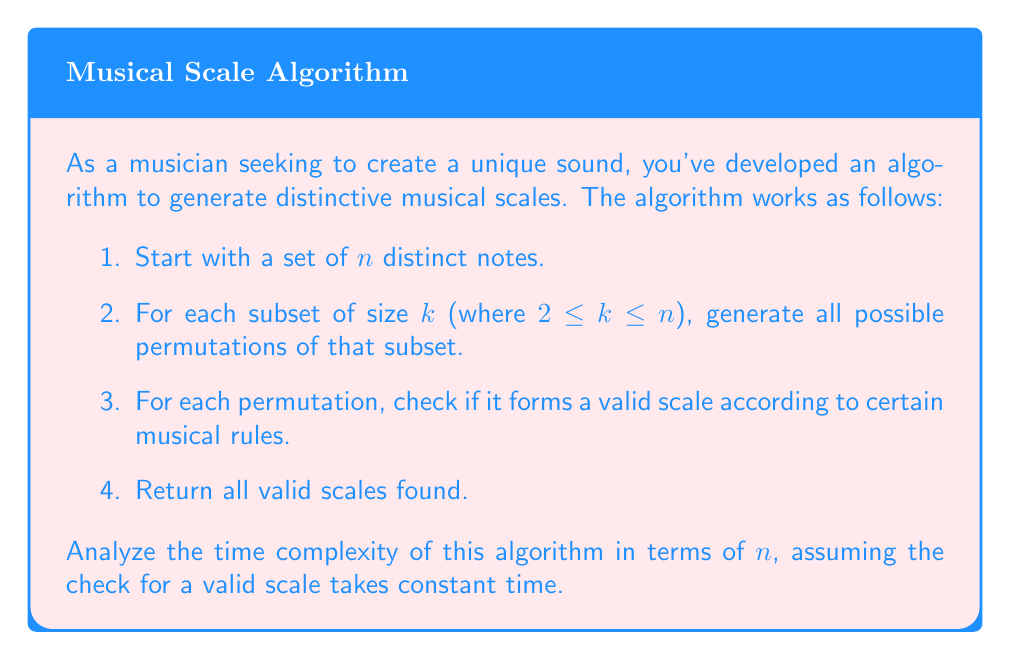Can you answer this question? To analyze the time complexity of this algorithm, let's break it down step by step:

1. We start with $n$ distinct notes.

2. For each subset size $k$ from 2 to $n$:
   a. We need to generate all subsets of size $k$ from $n$ notes. This is given by the combination formula: $\binom{n}{k}$
   b. For each subset, we generate all permutations. The number of permutations for a set of size $k$ is $k!$

3. For each permutation, we perform a constant-time check.

Therefore, the total number of operations is proportional to:

$$\sum_{k=2}^n \binom{n}{k} \cdot k!$$

We can simplify this using the following steps:

1. Recall that $\binom{n}{k} \cdot k! = n \cdot (n-1) \cdot ... \cdot (n-k+1) = \frac{n!}{(n-k)!}$

2. Substituting this into our sum:

   $$\sum_{k=2}^n \frac{n!}{(n-k)!}$$

3. This can be rewritten as:

   $$n! \cdot \sum_{k=2}^n \frac{1}{(n-k)!}$$

4. The sum $\sum_{k=2}^n \frac{1}{(n-k)!}$ is bounded above by $e - 2$, where $e$ is Euler's number.

5. Therefore, the time complexity is $O(n!)$.

This is a super-exponential time complexity, which means the algorithm becomes extremely slow for even moderately large values of $n$.
Answer: The time complexity of the algorithm is $O(n!)$. 